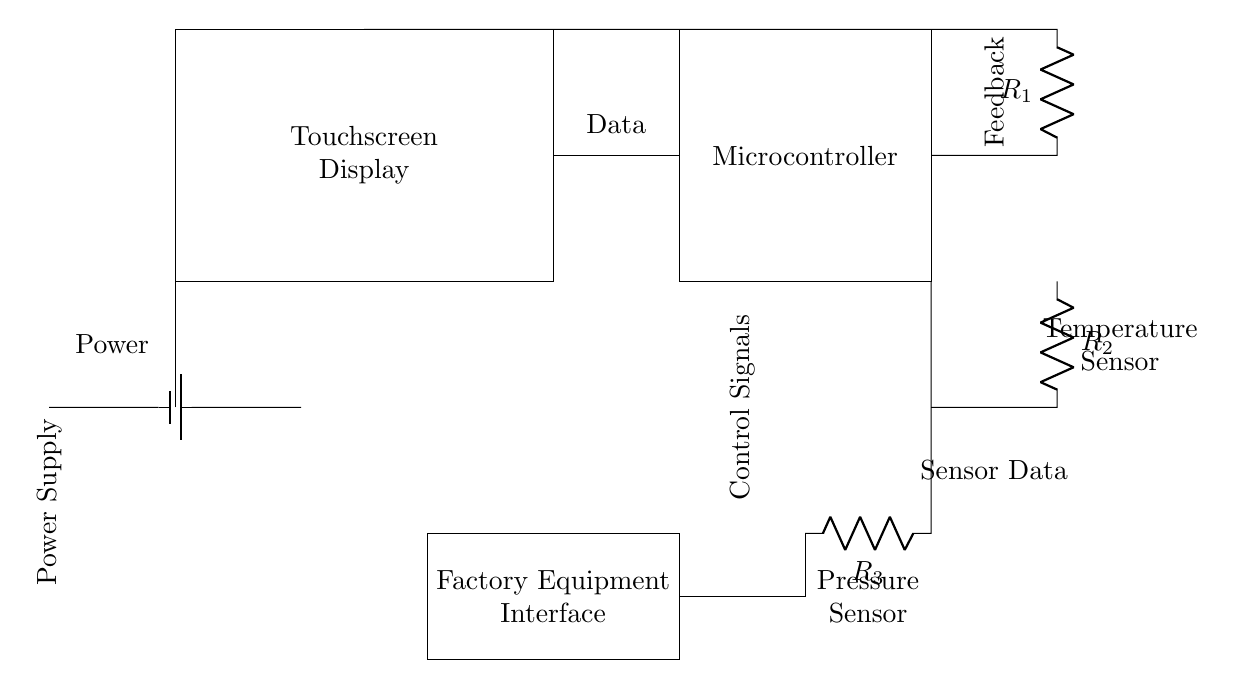What component acts as the primary user interface? The touchscreen display is the primary user interface, as it is designed for user interactions and controls in the circuit.
Answer: Touchscreen Display What is the role of the microcontroller? The microcontroller processes data and sends control signals to the factory equipment interface, managing the operation according to inputs from the touchscreen and sensors.
Answer: Processing Data How many resistors are present in the circuit? There are three resistors labeled R1, R2, and R3, identified by their respective positions in the circuit diagram.
Answer: Three What type of sensor is indicated in the circuit? The circuit includes a temperature sensor and a pressure sensor, indicated by their specific labeling and placements related to the microcontroller.
Answer: Temperature and Pressure What does the power supply provide? The power supply provides electrical energy to the entire circuit, allowing components like the touchscreen display and microcontroller to function properly.
Answer: Power What is the feedback derived from in this circuit? Feedback in this circuit comes primarily from the sensor data, which informs the microcontroller about the operating conditions to adjust controls accordingly.
Answer: Sensor Data What is the output connection type from the microcontroller? The output from the microcontroller consists of control signals that are directed towards the factory equipment interface, indicating the type of operation to be executed.
Answer: Control Signals 